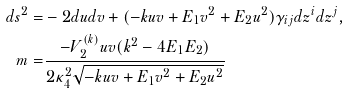Convert formula to latex. <formula><loc_0><loc_0><loc_500><loc_500>d s ^ { 2 } = & - 2 d u d v + ( - k u v + E _ { 1 } v ^ { 2 } + E _ { 2 } u ^ { 2 } ) \gamma _ { i j } d z ^ { i } d z ^ { j } , \\ m = & \frac { - V _ { 2 } ^ { ( k ) } u v ( k ^ { 2 } - 4 E _ { 1 } E _ { 2 } ) } { 2 \kappa _ { 4 } ^ { 2 } \sqrt { - k u v + E _ { 1 } v ^ { 2 } + E _ { 2 } u ^ { 2 } } }</formula> 